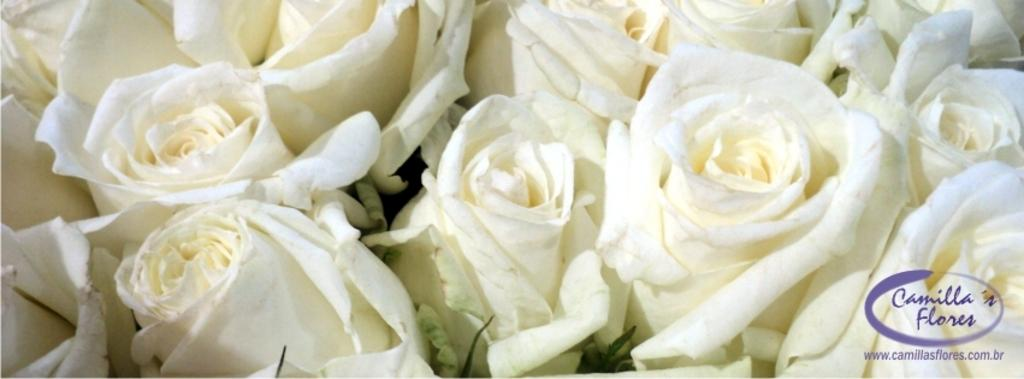What type of flowers are present in the image? There are many white roses in the image. Is there any text or message in the image? Yes, there is a small quote written on the bottom side of the image. Can you see any sea creatures swimming among the white roses in the image? No, there are no sea creatures present in the image; it features white roses and a quote. What type of straw is used to hold the white roses in the image? There is no straw present in the image; it only shows white roses and a quote. 